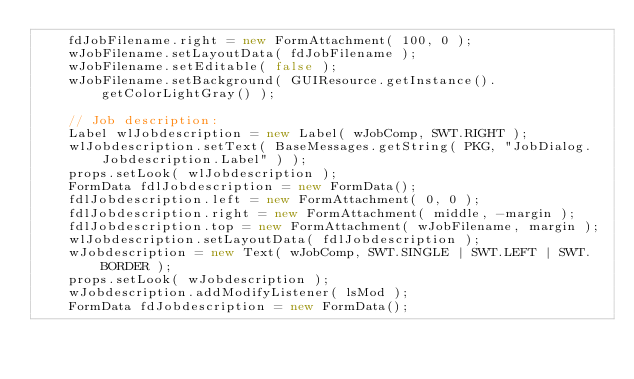<code> <loc_0><loc_0><loc_500><loc_500><_Java_>    fdJobFilename.right = new FormAttachment( 100, 0 );
    wJobFilename.setLayoutData( fdJobFilename );
    wJobFilename.setEditable( false );
    wJobFilename.setBackground( GUIResource.getInstance().getColorLightGray() );

    // Job description:
    Label wlJobdescription = new Label( wJobComp, SWT.RIGHT );
    wlJobdescription.setText( BaseMessages.getString( PKG, "JobDialog.Jobdescription.Label" ) );
    props.setLook( wlJobdescription );
    FormData fdlJobdescription = new FormData();
    fdlJobdescription.left = new FormAttachment( 0, 0 );
    fdlJobdescription.right = new FormAttachment( middle, -margin );
    fdlJobdescription.top = new FormAttachment( wJobFilename, margin );
    wlJobdescription.setLayoutData( fdlJobdescription );
    wJobdescription = new Text( wJobComp, SWT.SINGLE | SWT.LEFT | SWT.BORDER );
    props.setLook( wJobdescription );
    wJobdescription.addModifyListener( lsMod );
    FormData fdJobdescription = new FormData();</code> 